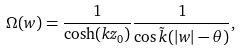<formula> <loc_0><loc_0><loc_500><loc_500>\Omega ( w ) = \frac { 1 } { \cosh ( k z _ { 0 } ) } \frac { 1 } { \cos \tilde { k } ( | w | - \theta ) } ,</formula> 